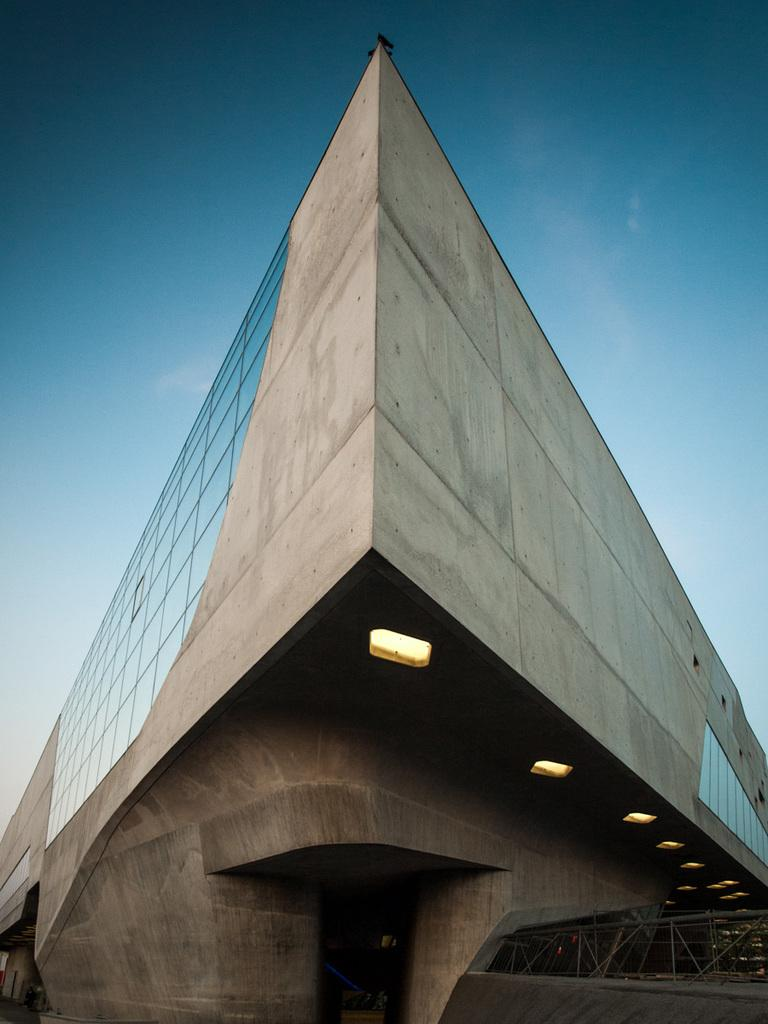What type of structure is visible in the image? There is a building in the image. What material or feature can be seen on the building? The building has glass elements. Are there any additional features visible on the building? Yes, there are lights on the building. Can you see a deer standing next to the building in the image? No, there is no deer present in the image. Is there a dog holding a pencil in the image? No, there is no dog or pencil present in the image. 